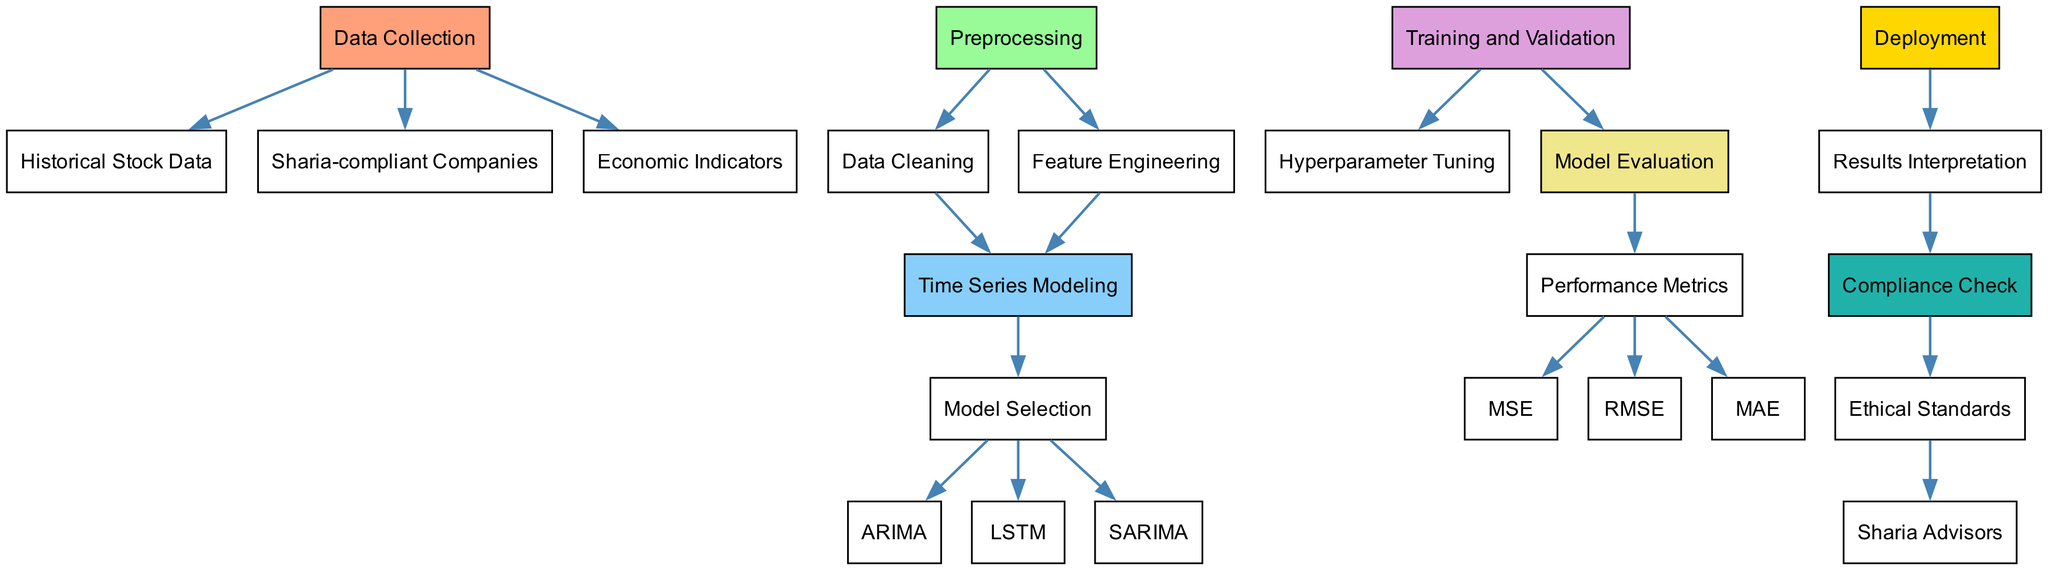What is the first step in the diagram? The diagram begins with the 'Data Collection' node, which is the initial step in the process.
Answer: Data Collection How many types of time series models are represented? Three different models are identified in the diagram: ARIMA, LSTM, and SARIMA, which are connected under the 'Model Selection' node.
Answer: Three Which node follows 'Data Cleaning'? The node 'Time Series Modeling' follows 'Data Cleaning' in the flow of the process, indicating the next stage after cleaning the data.
Answer: Time Series Modeling What type of companies are being focused on in this diagram? The diagram highlights 'Sharia-compliant Companies' as a key element in the investment process, indicating the ethical focus of the portfolio.
Answer: Sharia-compliant Companies What is the last step in the diagram? The final step represented in the diagram is 'Results Interpretation', indicating the conclusion of the process where findings are assessed.
Answer: Results Interpretation What relationship links 'Feature Engineering' to 'Time Series Modeling'? 'Feature Engineering' serves as a necessary precursor to 'Time Series Modeling', meaning that features must be engineered before modeling can take place.
Answer: It is a prerequisite Which performance metric is NOT mentioned in the diagram? The performance metrics 'R²' is not included in the diagram; it lists only MSE, RMSE, and MAE as evaluated metrics.
Answer: R² What role do 'Sharia Advisors' play in this process? 'Sharia Advisors' provide guidance on compliance with Islamic financial laws, ensuring that investments adhere to ethical standards.
Answer: Compliance guidance How many preprocessing steps does the diagram show? There are two preprocessing steps: 'Data Cleaning' and 'Feature Engineering', as indicated by their connection to the 'Preprocessing' node.
Answer: Two 